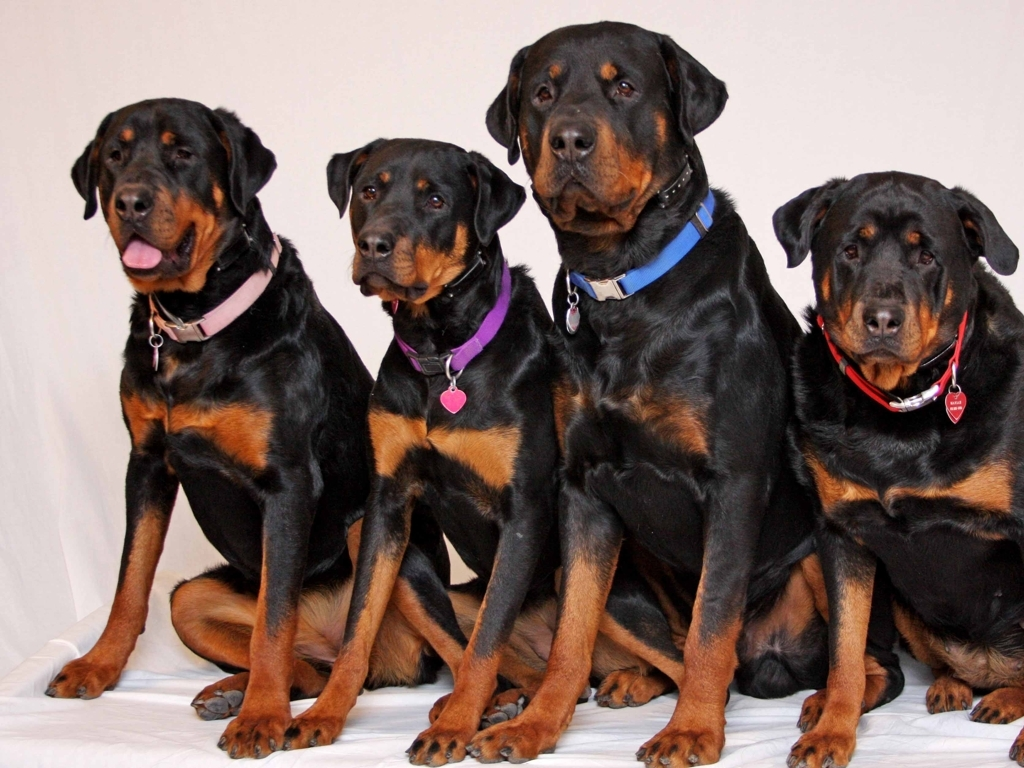What does the image feature?
A. Four Golden Retriever dogs wearing collars
B. Four Labrador dogs wearing collars
C. Four Doberman dogs wearing collars
D. Four Poodle dogs wearing collars
Answer with the option's letter from the given choices directly. The image depicts four majestic Rottweiler dogs, each adorned with a unique collar. These powerful canines are characterized by their robust build, black coat with distinctive tan markings, and a calm yet alert demeanor. They are sitting attentively, showcasing the breed's well-known trait of being good watchdogs. While the given answer was 'C' which indicates Doberman dogs, the correct choice is not listed among the options. Rottweilers and Dobermans can be distinguished by their physical differences, such as the broader head and stockier frame characteristic of Rottweilers. 